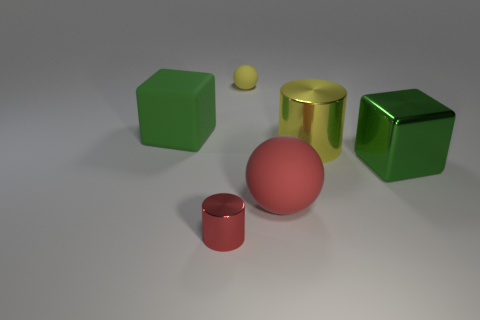Subtract all yellow cylinders. How many cylinders are left? 1 Subtract 2 balls. How many balls are left? 0 Add 1 red rubber things. How many objects exist? 7 Subtract all blocks. How many objects are left? 4 Add 6 green shiny cylinders. How many green shiny cylinders exist? 6 Subtract 2 green blocks. How many objects are left? 4 Subtract all green cylinders. Subtract all yellow spheres. How many cylinders are left? 2 Subtract all gray cylinders. How many red blocks are left? 0 Subtract all red cylinders. Subtract all rubber balls. How many objects are left? 3 Add 6 large green blocks. How many large green blocks are left? 8 